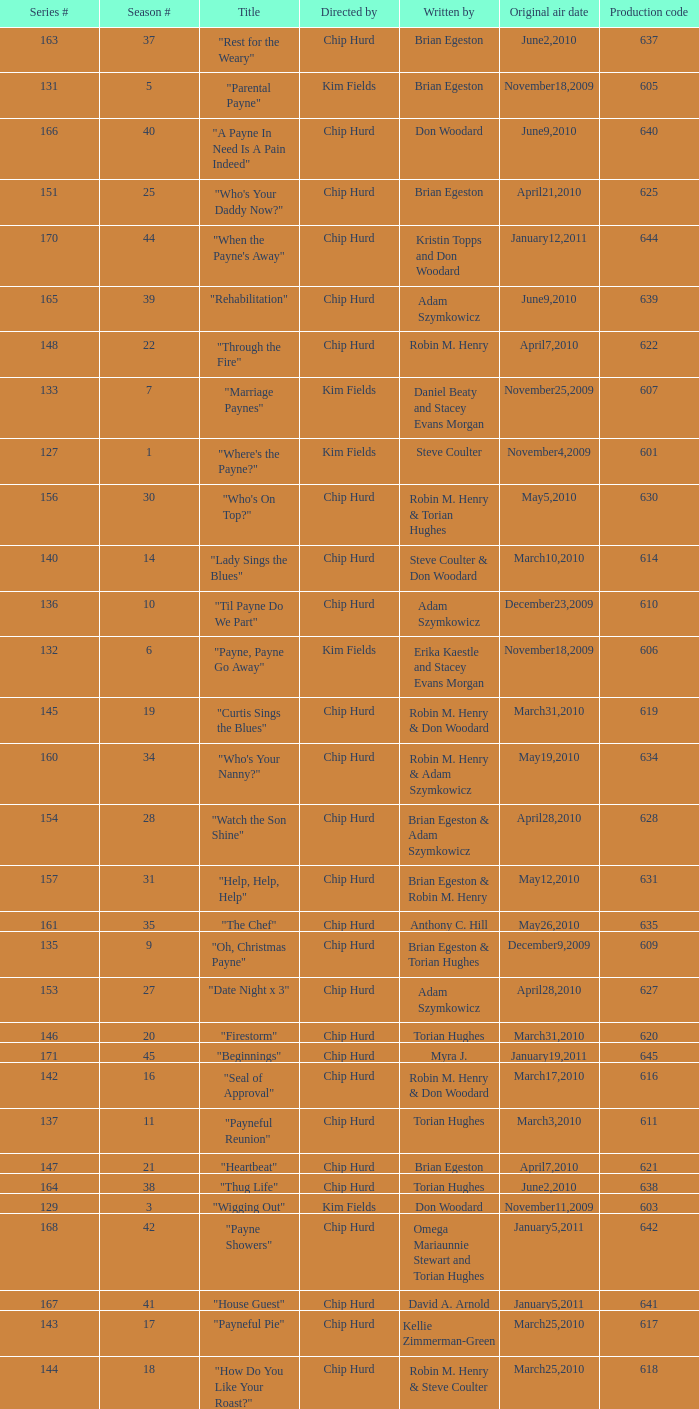What is the title of the episode with the production code 624? "Matured Investment". 